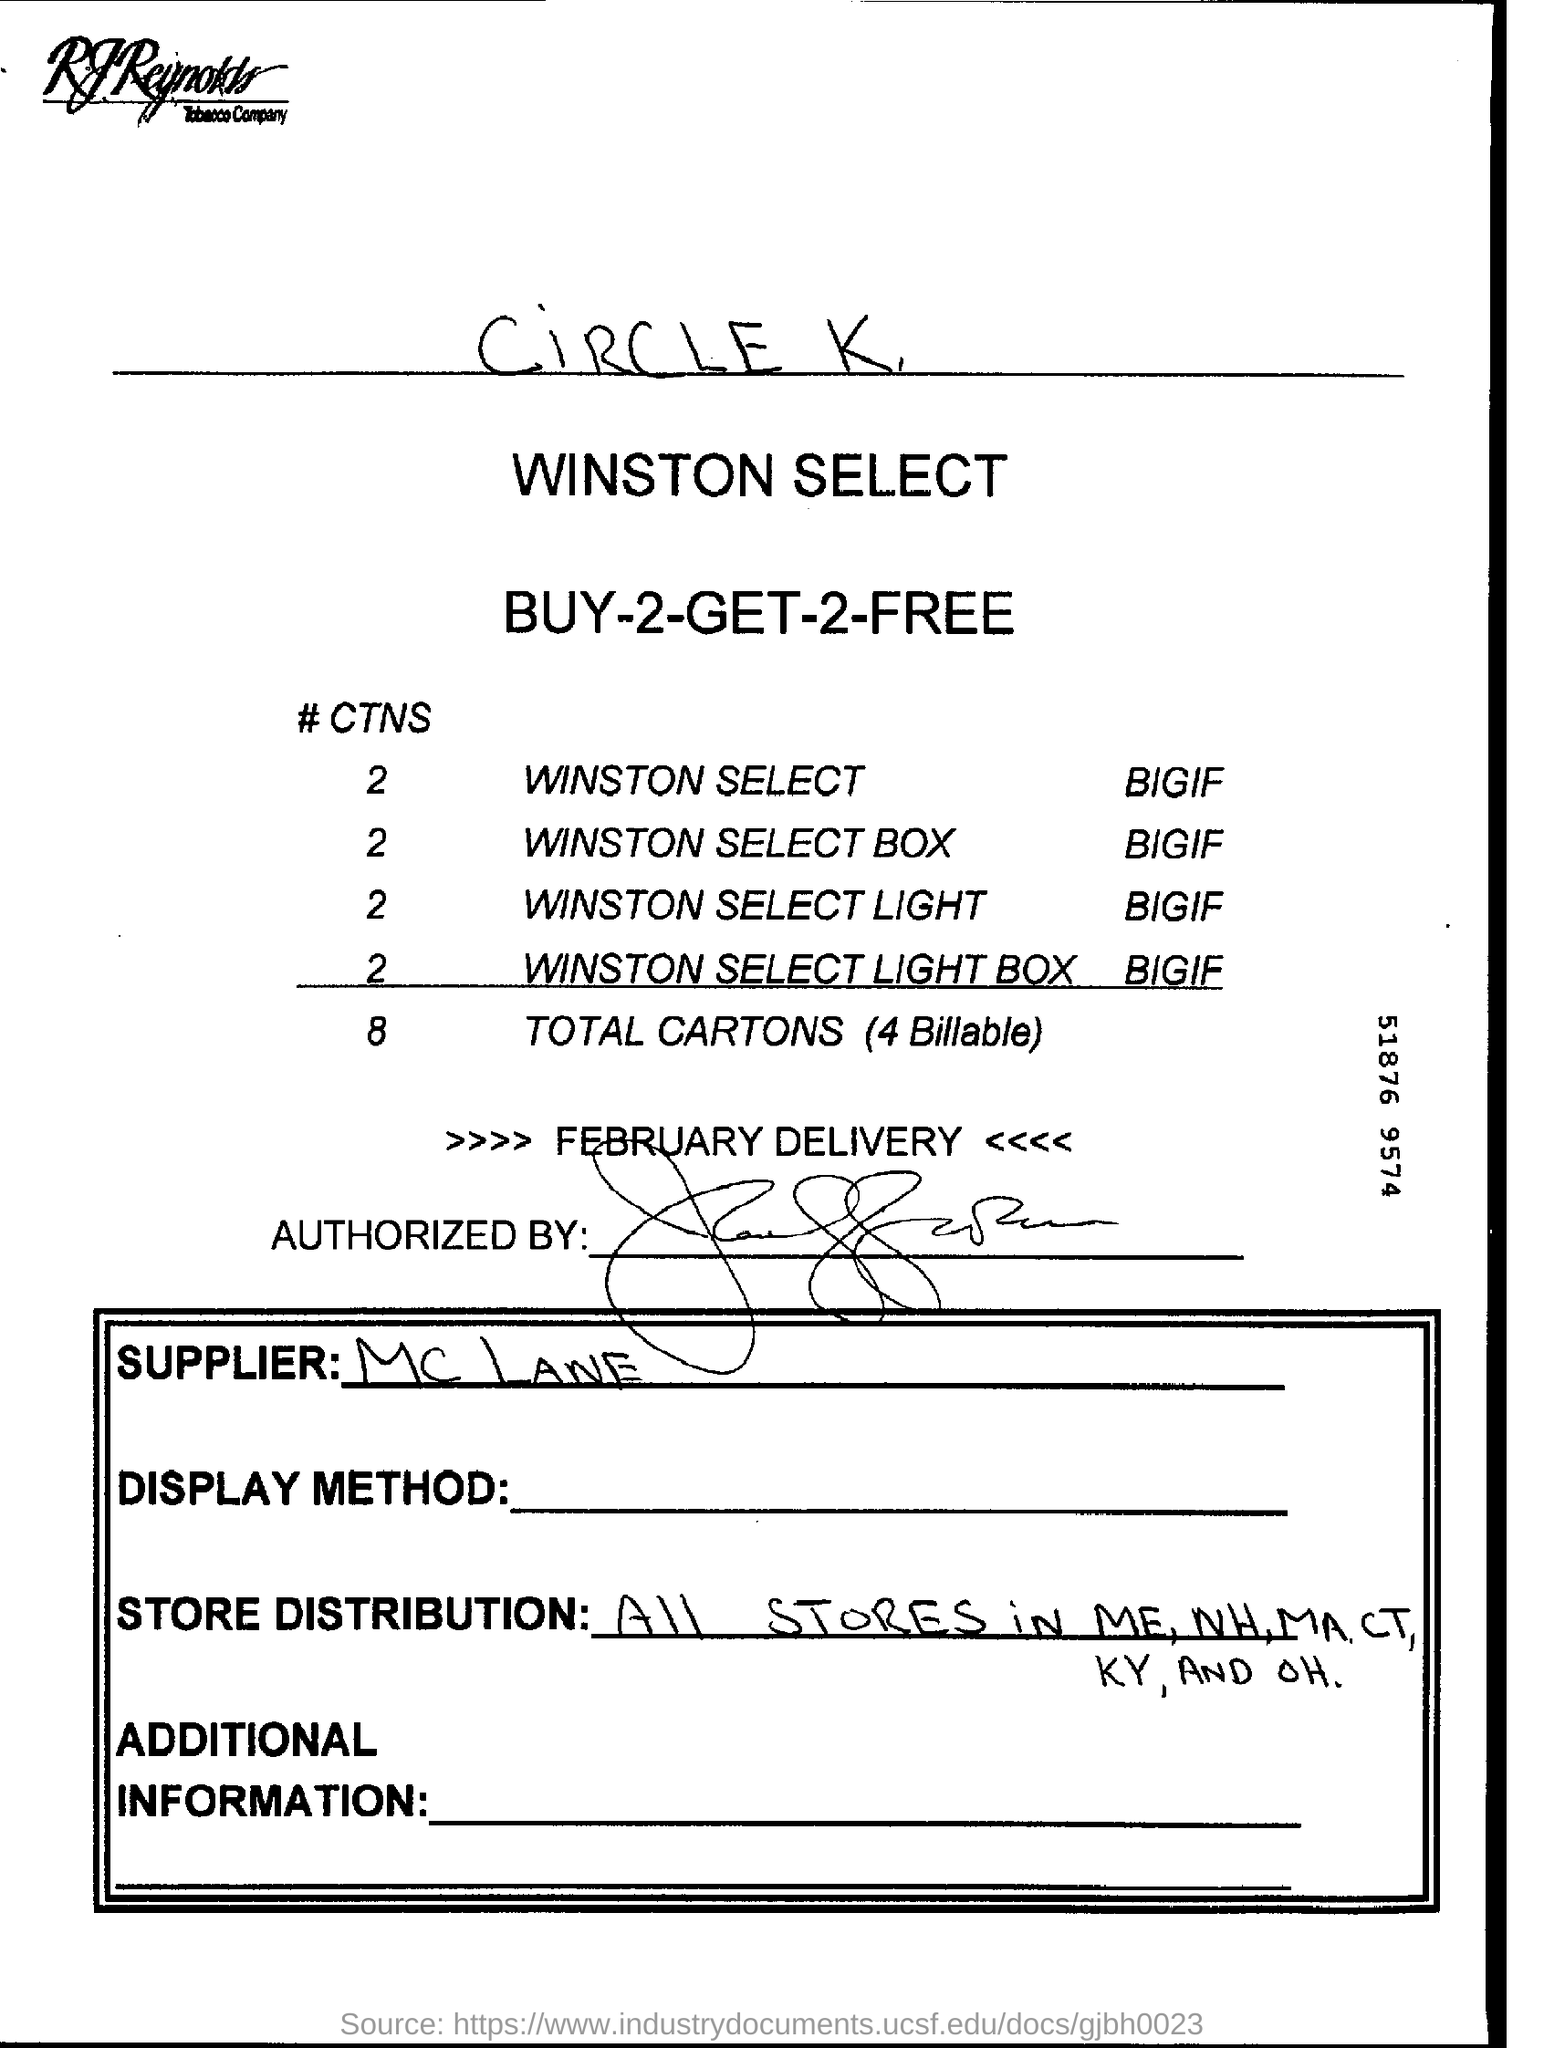What is hand written on top of the page?
Provide a short and direct response. Circle k. Which month's delivery is mentioned in this page?
Ensure brevity in your answer.  >>>> february delivery <<<<. 